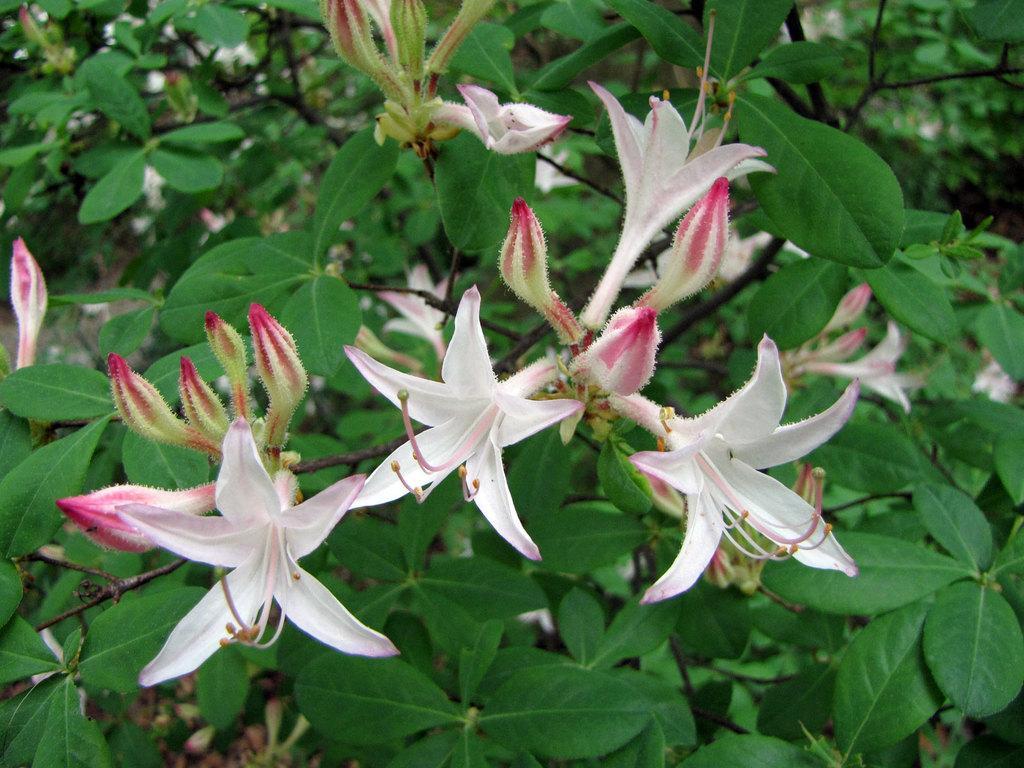Can you describe this image briefly? This picture is clicked outside. In the center we can see the flowers and the buds and we can see the green leaves of the plants. In the background we can see the plants. 